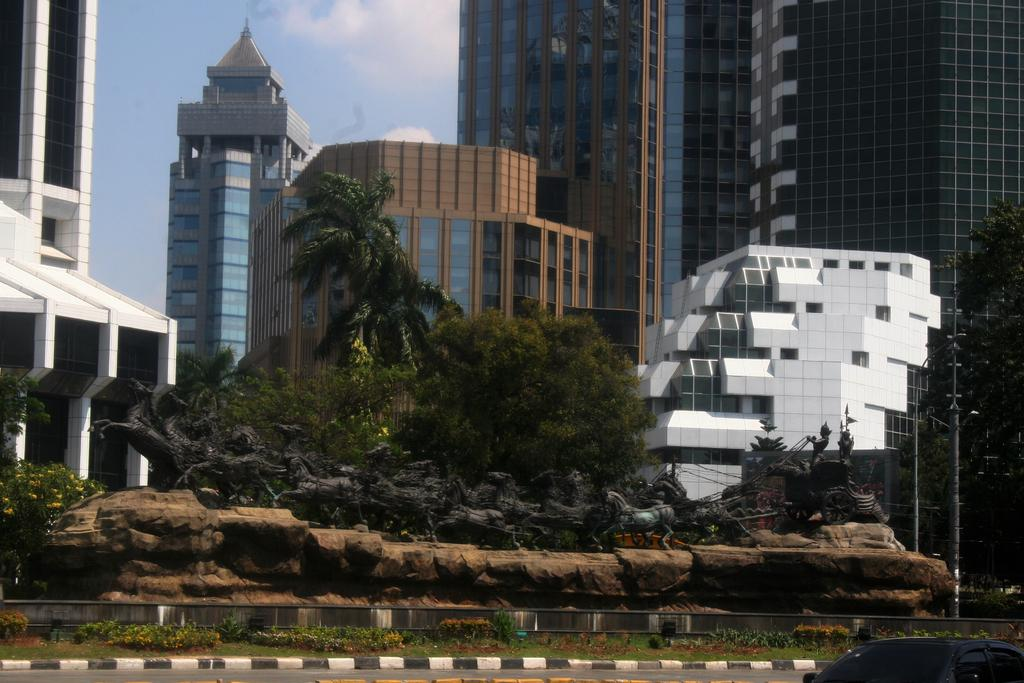What type of natural elements can be seen in the image? There are trees, plants, and flowers in the image. What type of man-made structures are present in the image? There are buildings and statues in the image. What type of transportation can be seen in the image? There is a car in the image. What type of infrastructure is present in the image? There is a road and poles in the image. What is visible in the sky in the image? The sky is visible, and there are clouds in the image. What type of jam is being spread on the horse in the image? There is no jam or horse present in the image. What is the temper of the person in the image? There is no person present in the image, so it is not possible to determine their temper. 